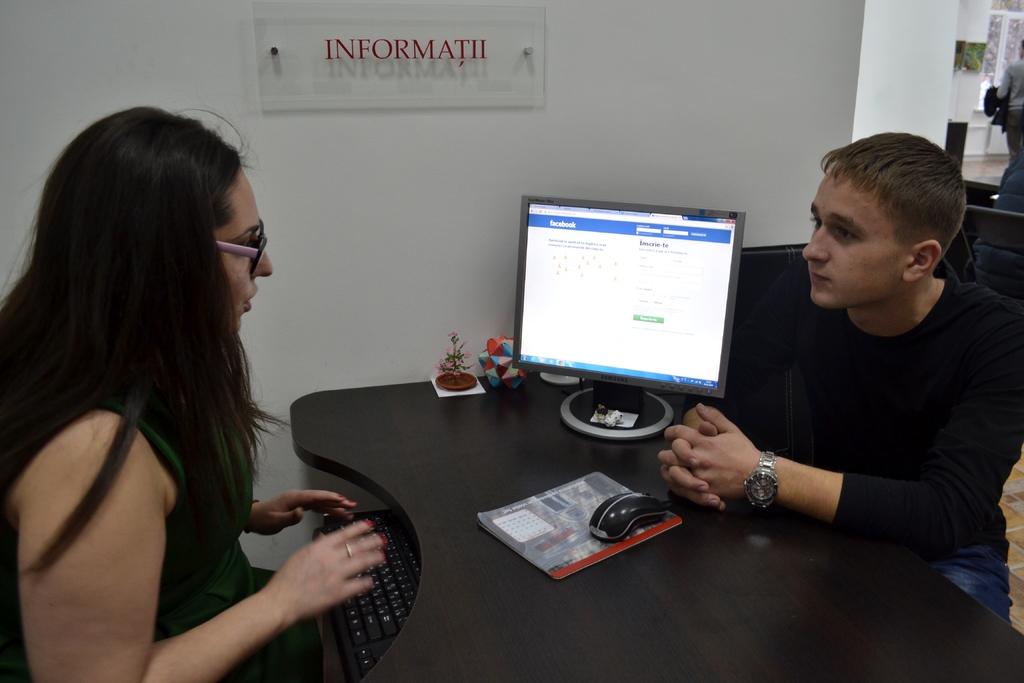Are they viewing facebook?
Give a very brief answer. Yes. What does the sign on the wall say?
Make the answer very short. Informatii. 